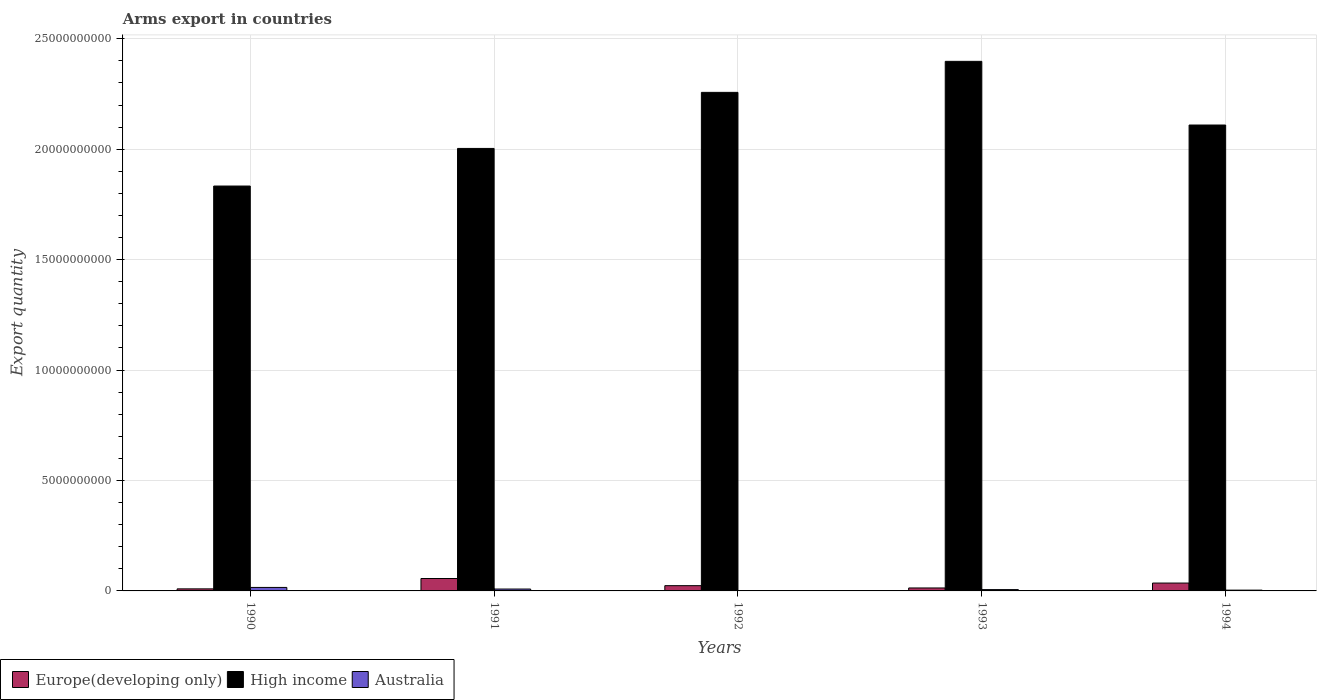How many groups of bars are there?
Provide a short and direct response. 5. Are the number of bars per tick equal to the number of legend labels?
Give a very brief answer. Yes. Are the number of bars on each tick of the X-axis equal?
Provide a short and direct response. Yes. How many bars are there on the 3rd tick from the right?
Offer a terse response. 3. In how many cases, is the number of bars for a given year not equal to the number of legend labels?
Offer a very short reply. 0. What is the total arms export in Europe(developing only) in 1994?
Your answer should be compact. 3.56e+08. Across all years, what is the maximum total arms export in Australia?
Offer a terse response. 1.58e+08. Across all years, what is the minimum total arms export in High income?
Keep it short and to the point. 1.83e+1. In which year was the total arms export in Australia minimum?
Offer a very short reply. 1992. What is the total total arms export in Australia in the graph?
Your response must be concise. 3.45e+08. What is the difference between the total arms export in Europe(developing only) in 1993 and that in 1994?
Provide a succinct answer. -2.22e+08. What is the difference between the total arms export in High income in 1992 and the total arms export in Europe(developing only) in 1991?
Your response must be concise. 2.20e+1. What is the average total arms export in Europe(developing only) per year?
Ensure brevity in your answer.  2.77e+08. In the year 1990, what is the difference between the total arms export in Australia and total arms export in High income?
Your answer should be compact. -1.82e+1. In how many years, is the total arms export in High income greater than 21000000000?
Your answer should be very brief. 3. What is the ratio of the total arms export in High income in 1993 to that in 1994?
Your answer should be very brief. 1.14. What is the difference between the highest and the second highest total arms export in Europe(developing only)?
Provide a succinct answer. 2.06e+08. What is the difference between the highest and the lowest total arms export in Australia?
Keep it short and to the point. 1.52e+08. In how many years, is the total arms export in Australia greater than the average total arms export in Australia taken over all years?
Your response must be concise. 2. Is the sum of the total arms export in Australia in 1990 and 1993 greater than the maximum total arms export in High income across all years?
Ensure brevity in your answer.  No. What does the 3rd bar from the left in 1994 represents?
Offer a terse response. Australia. How many years are there in the graph?
Give a very brief answer. 5. What is the difference between two consecutive major ticks on the Y-axis?
Provide a short and direct response. 5.00e+09. Does the graph contain grids?
Your answer should be compact. Yes. Where does the legend appear in the graph?
Give a very brief answer. Bottom left. How are the legend labels stacked?
Provide a short and direct response. Horizontal. What is the title of the graph?
Provide a short and direct response. Arms export in countries. What is the label or title of the X-axis?
Give a very brief answer. Years. What is the label or title of the Y-axis?
Keep it short and to the point. Export quantity. What is the Export quantity in Europe(developing only) in 1990?
Provide a succinct answer. 9.30e+07. What is the Export quantity of High income in 1990?
Give a very brief answer. 1.83e+1. What is the Export quantity in Australia in 1990?
Offer a terse response. 1.58e+08. What is the Export quantity of Europe(developing only) in 1991?
Provide a short and direct response. 5.62e+08. What is the Export quantity in High income in 1991?
Your answer should be compact. 2.00e+1. What is the Export quantity of Australia in 1991?
Your response must be concise. 8.50e+07. What is the Export quantity of Europe(developing only) in 1992?
Offer a terse response. 2.38e+08. What is the Export quantity in High income in 1992?
Provide a short and direct response. 2.26e+1. What is the Export quantity of Europe(developing only) in 1993?
Make the answer very short. 1.34e+08. What is the Export quantity of High income in 1993?
Ensure brevity in your answer.  2.40e+1. What is the Export quantity of Australia in 1993?
Keep it short and to the point. 6.00e+07. What is the Export quantity of Europe(developing only) in 1994?
Your response must be concise. 3.56e+08. What is the Export quantity of High income in 1994?
Keep it short and to the point. 2.11e+1. What is the Export quantity of Australia in 1994?
Your answer should be compact. 3.60e+07. Across all years, what is the maximum Export quantity of Europe(developing only)?
Keep it short and to the point. 5.62e+08. Across all years, what is the maximum Export quantity of High income?
Your answer should be compact. 2.40e+1. Across all years, what is the maximum Export quantity of Australia?
Your answer should be compact. 1.58e+08. Across all years, what is the minimum Export quantity in Europe(developing only)?
Provide a short and direct response. 9.30e+07. Across all years, what is the minimum Export quantity of High income?
Offer a terse response. 1.83e+1. Across all years, what is the minimum Export quantity in Australia?
Offer a very short reply. 6.00e+06. What is the total Export quantity of Europe(developing only) in the graph?
Keep it short and to the point. 1.38e+09. What is the total Export quantity in High income in the graph?
Offer a very short reply. 1.06e+11. What is the total Export quantity of Australia in the graph?
Provide a short and direct response. 3.45e+08. What is the difference between the Export quantity of Europe(developing only) in 1990 and that in 1991?
Provide a succinct answer. -4.69e+08. What is the difference between the Export quantity of High income in 1990 and that in 1991?
Offer a very short reply. -1.70e+09. What is the difference between the Export quantity of Australia in 1990 and that in 1991?
Your answer should be compact. 7.30e+07. What is the difference between the Export quantity of Europe(developing only) in 1990 and that in 1992?
Provide a short and direct response. -1.45e+08. What is the difference between the Export quantity of High income in 1990 and that in 1992?
Make the answer very short. -4.24e+09. What is the difference between the Export quantity of Australia in 1990 and that in 1992?
Give a very brief answer. 1.52e+08. What is the difference between the Export quantity of Europe(developing only) in 1990 and that in 1993?
Your response must be concise. -4.10e+07. What is the difference between the Export quantity in High income in 1990 and that in 1993?
Give a very brief answer. -5.65e+09. What is the difference between the Export quantity of Australia in 1990 and that in 1993?
Your answer should be very brief. 9.80e+07. What is the difference between the Export quantity in Europe(developing only) in 1990 and that in 1994?
Give a very brief answer. -2.63e+08. What is the difference between the Export quantity in High income in 1990 and that in 1994?
Keep it short and to the point. -2.76e+09. What is the difference between the Export quantity of Australia in 1990 and that in 1994?
Your response must be concise. 1.22e+08. What is the difference between the Export quantity in Europe(developing only) in 1991 and that in 1992?
Give a very brief answer. 3.24e+08. What is the difference between the Export quantity in High income in 1991 and that in 1992?
Ensure brevity in your answer.  -2.54e+09. What is the difference between the Export quantity in Australia in 1991 and that in 1992?
Make the answer very short. 7.90e+07. What is the difference between the Export quantity of Europe(developing only) in 1991 and that in 1993?
Keep it short and to the point. 4.28e+08. What is the difference between the Export quantity of High income in 1991 and that in 1993?
Offer a very short reply. -3.94e+09. What is the difference between the Export quantity of Australia in 1991 and that in 1993?
Keep it short and to the point. 2.50e+07. What is the difference between the Export quantity in Europe(developing only) in 1991 and that in 1994?
Offer a very short reply. 2.06e+08. What is the difference between the Export quantity of High income in 1991 and that in 1994?
Ensure brevity in your answer.  -1.06e+09. What is the difference between the Export quantity of Australia in 1991 and that in 1994?
Provide a succinct answer. 4.90e+07. What is the difference between the Export quantity in Europe(developing only) in 1992 and that in 1993?
Ensure brevity in your answer.  1.04e+08. What is the difference between the Export quantity of High income in 1992 and that in 1993?
Offer a terse response. -1.40e+09. What is the difference between the Export quantity of Australia in 1992 and that in 1993?
Ensure brevity in your answer.  -5.40e+07. What is the difference between the Export quantity in Europe(developing only) in 1992 and that in 1994?
Offer a terse response. -1.18e+08. What is the difference between the Export quantity of High income in 1992 and that in 1994?
Your answer should be very brief. 1.48e+09. What is the difference between the Export quantity of Australia in 1992 and that in 1994?
Keep it short and to the point. -3.00e+07. What is the difference between the Export quantity of Europe(developing only) in 1993 and that in 1994?
Provide a short and direct response. -2.22e+08. What is the difference between the Export quantity in High income in 1993 and that in 1994?
Offer a terse response. 2.88e+09. What is the difference between the Export quantity in Australia in 1993 and that in 1994?
Give a very brief answer. 2.40e+07. What is the difference between the Export quantity in Europe(developing only) in 1990 and the Export quantity in High income in 1991?
Your response must be concise. -1.99e+1. What is the difference between the Export quantity in Europe(developing only) in 1990 and the Export quantity in Australia in 1991?
Make the answer very short. 8.00e+06. What is the difference between the Export quantity of High income in 1990 and the Export quantity of Australia in 1991?
Provide a short and direct response. 1.82e+1. What is the difference between the Export quantity of Europe(developing only) in 1990 and the Export quantity of High income in 1992?
Your answer should be very brief. -2.25e+1. What is the difference between the Export quantity of Europe(developing only) in 1990 and the Export quantity of Australia in 1992?
Make the answer very short. 8.70e+07. What is the difference between the Export quantity in High income in 1990 and the Export quantity in Australia in 1992?
Your response must be concise. 1.83e+1. What is the difference between the Export quantity of Europe(developing only) in 1990 and the Export quantity of High income in 1993?
Your answer should be compact. -2.39e+1. What is the difference between the Export quantity of Europe(developing only) in 1990 and the Export quantity of Australia in 1993?
Your response must be concise. 3.30e+07. What is the difference between the Export quantity in High income in 1990 and the Export quantity in Australia in 1993?
Provide a succinct answer. 1.83e+1. What is the difference between the Export quantity in Europe(developing only) in 1990 and the Export quantity in High income in 1994?
Your response must be concise. -2.10e+1. What is the difference between the Export quantity of Europe(developing only) in 1990 and the Export quantity of Australia in 1994?
Offer a terse response. 5.70e+07. What is the difference between the Export quantity of High income in 1990 and the Export quantity of Australia in 1994?
Offer a terse response. 1.83e+1. What is the difference between the Export quantity of Europe(developing only) in 1991 and the Export quantity of High income in 1992?
Provide a short and direct response. -2.20e+1. What is the difference between the Export quantity in Europe(developing only) in 1991 and the Export quantity in Australia in 1992?
Offer a very short reply. 5.56e+08. What is the difference between the Export quantity in High income in 1991 and the Export quantity in Australia in 1992?
Your answer should be very brief. 2.00e+1. What is the difference between the Export quantity in Europe(developing only) in 1991 and the Export quantity in High income in 1993?
Ensure brevity in your answer.  -2.34e+1. What is the difference between the Export quantity of Europe(developing only) in 1991 and the Export quantity of Australia in 1993?
Offer a very short reply. 5.02e+08. What is the difference between the Export quantity in High income in 1991 and the Export quantity in Australia in 1993?
Make the answer very short. 2.00e+1. What is the difference between the Export quantity in Europe(developing only) in 1991 and the Export quantity in High income in 1994?
Your answer should be very brief. -2.05e+1. What is the difference between the Export quantity of Europe(developing only) in 1991 and the Export quantity of Australia in 1994?
Keep it short and to the point. 5.26e+08. What is the difference between the Export quantity of Europe(developing only) in 1992 and the Export quantity of High income in 1993?
Ensure brevity in your answer.  -2.37e+1. What is the difference between the Export quantity of Europe(developing only) in 1992 and the Export quantity of Australia in 1993?
Offer a terse response. 1.78e+08. What is the difference between the Export quantity of High income in 1992 and the Export quantity of Australia in 1993?
Give a very brief answer. 2.25e+1. What is the difference between the Export quantity in Europe(developing only) in 1992 and the Export quantity in High income in 1994?
Offer a terse response. -2.09e+1. What is the difference between the Export quantity in Europe(developing only) in 1992 and the Export quantity in Australia in 1994?
Make the answer very short. 2.02e+08. What is the difference between the Export quantity of High income in 1992 and the Export quantity of Australia in 1994?
Offer a very short reply. 2.25e+1. What is the difference between the Export quantity of Europe(developing only) in 1993 and the Export quantity of High income in 1994?
Ensure brevity in your answer.  -2.10e+1. What is the difference between the Export quantity of Europe(developing only) in 1993 and the Export quantity of Australia in 1994?
Your answer should be compact. 9.80e+07. What is the difference between the Export quantity in High income in 1993 and the Export quantity in Australia in 1994?
Keep it short and to the point. 2.39e+1. What is the average Export quantity of Europe(developing only) per year?
Offer a very short reply. 2.77e+08. What is the average Export quantity of High income per year?
Provide a succinct answer. 2.12e+1. What is the average Export quantity of Australia per year?
Ensure brevity in your answer.  6.90e+07. In the year 1990, what is the difference between the Export quantity in Europe(developing only) and Export quantity in High income?
Your answer should be very brief. -1.82e+1. In the year 1990, what is the difference between the Export quantity of Europe(developing only) and Export quantity of Australia?
Ensure brevity in your answer.  -6.50e+07. In the year 1990, what is the difference between the Export quantity in High income and Export quantity in Australia?
Your answer should be compact. 1.82e+1. In the year 1991, what is the difference between the Export quantity of Europe(developing only) and Export quantity of High income?
Offer a very short reply. -1.95e+1. In the year 1991, what is the difference between the Export quantity of Europe(developing only) and Export quantity of Australia?
Your answer should be compact. 4.77e+08. In the year 1991, what is the difference between the Export quantity in High income and Export quantity in Australia?
Offer a very short reply. 2.00e+1. In the year 1992, what is the difference between the Export quantity in Europe(developing only) and Export quantity in High income?
Offer a very short reply. -2.23e+1. In the year 1992, what is the difference between the Export quantity in Europe(developing only) and Export quantity in Australia?
Your response must be concise. 2.32e+08. In the year 1992, what is the difference between the Export quantity of High income and Export quantity of Australia?
Your answer should be very brief. 2.26e+1. In the year 1993, what is the difference between the Export quantity of Europe(developing only) and Export quantity of High income?
Your response must be concise. -2.38e+1. In the year 1993, what is the difference between the Export quantity in Europe(developing only) and Export quantity in Australia?
Make the answer very short. 7.40e+07. In the year 1993, what is the difference between the Export quantity in High income and Export quantity in Australia?
Your answer should be very brief. 2.39e+1. In the year 1994, what is the difference between the Export quantity in Europe(developing only) and Export quantity in High income?
Your answer should be very brief. -2.07e+1. In the year 1994, what is the difference between the Export quantity of Europe(developing only) and Export quantity of Australia?
Keep it short and to the point. 3.20e+08. In the year 1994, what is the difference between the Export quantity of High income and Export quantity of Australia?
Offer a terse response. 2.11e+1. What is the ratio of the Export quantity in Europe(developing only) in 1990 to that in 1991?
Your response must be concise. 0.17. What is the ratio of the Export quantity in High income in 1990 to that in 1991?
Offer a very short reply. 0.92. What is the ratio of the Export quantity in Australia in 1990 to that in 1991?
Keep it short and to the point. 1.86. What is the ratio of the Export quantity of Europe(developing only) in 1990 to that in 1992?
Provide a succinct answer. 0.39. What is the ratio of the Export quantity of High income in 1990 to that in 1992?
Make the answer very short. 0.81. What is the ratio of the Export quantity in Australia in 1990 to that in 1992?
Your answer should be compact. 26.33. What is the ratio of the Export quantity of Europe(developing only) in 1990 to that in 1993?
Make the answer very short. 0.69. What is the ratio of the Export quantity in High income in 1990 to that in 1993?
Keep it short and to the point. 0.76. What is the ratio of the Export quantity in Australia in 1990 to that in 1993?
Your answer should be compact. 2.63. What is the ratio of the Export quantity in Europe(developing only) in 1990 to that in 1994?
Give a very brief answer. 0.26. What is the ratio of the Export quantity in High income in 1990 to that in 1994?
Ensure brevity in your answer.  0.87. What is the ratio of the Export quantity in Australia in 1990 to that in 1994?
Provide a succinct answer. 4.39. What is the ratio of the Export quantity in Europe(developing only) in 1991 to that in 1992?
Ensure brevity in your answer.  2.36. What is the ratio of the Export quantity of High income in 1991 to that in 1992?
Your answer should be very brief. 0.89. What is the ratio of the Export quantity in Australia in 1991 to that in 1992?
Provide a succinct answer. 14.17. What is the ratio of the Export quantity in Europe(developing only) in 1991 to that in 1993?
Offer a terse response. 4.19. What is the ratio of the Export quantity in High income in 1991 to that in 1993?
Offer a very short reply. 0.84. What is the ratio of the Export quantity in Australia in 1991 to that in 1993?
Offer a very short reply. 1.42. What is the ratio of the Export quantity in Europe(developing only) in 1991 to that in 1994?
Make the answer very short. 1.58. What is the ratio of the Export quantity of High income in 1991 to that in 1994?
Provide a short and direct response. 0.95. What is the ratio of the Export quantity in Australia in 1991 to that in 1994?
Provide a succinct answer. 2.36. What is the ratio of the Export quantity of Europe(developing only) in 1992 to that in 1993?
Give a very brief answer. 1.78. What is the ratio of the Export quantity of High income in 1992 to that in 1993?
Your answer should be compact. 0.94. What is the ratio of the Export quantity in Australia in 1992 to that in 1993?
Offer a very short reply. 0.1. What is the ratio of the Export quantity in Europe(developing only) in 1992 to that in 1994?
Make the answer very short. 0.67. What is the ratio of the Export quantity of High income in 1992 to that in 1994?
Keep it short and to the point. 1.07. What is the ratio of the Export quantity in Europe(developing only) in 1993 to that in 1994?
Your answer should be very brief. 0.38. What is the ratio of the Export quantity of High income in 1993 to that in 1994?
Keep it short and to the point. 1.14. What is the ratio of the Export quantity in Australia in 1993 to that in 1994?
Ensure brevity in your answer.  1.67. What is the difference between the highest and the second highest Export quantity of Europe(developing only)?
Provide a short and direct response. 2.06e+08. What is the difference between the highest and the second highest Export quantity in High income?
Ensure brevity in your answer.  1.40e+09. What is the difference between the highest and the second highest Export quantity of Australia?
Ensure brevity in your answer.  7.30e+07. What is the difference between the highest and the lowest Export quantity of Europe(developing only)?
Give a very brief answer. 4.69e+08. What is the difference between the highest and the lowest Export quantity of High income?
Ensure brevity in your answer.  5.65e+09. What is the difference between the highest and the lowest Export quantity of Australia?
Your answer should be compact. 1.52e+08. 